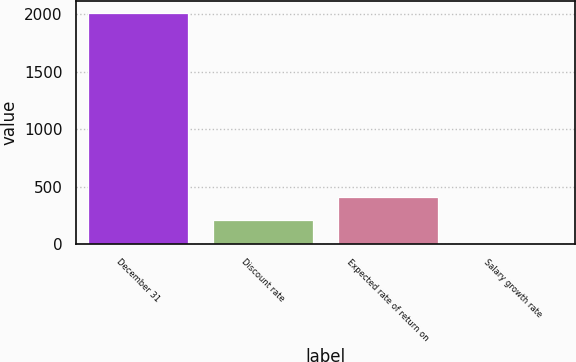<chart> <loc_0><loc_0><loc_500><loc_500><bar_chart><fcel>December 31<fcel>Discount rate<fcel>Expected rate of return on<fcel>Salary growth rate<nl><fcel>2012<fcel>205.25<fcel>406<fcel>4.5<nl></chart> 